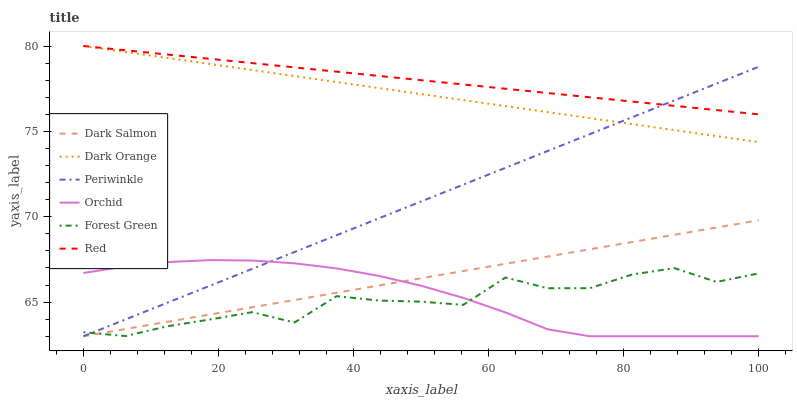Does Forest Green have the minimum area under the curve?
Answer yes or no. Yes. Does Red have the maximum area under the curve?
Answer yes or no. Yes. Does Dark Salmon have the minimum area under the curve?
Answer yes or no. No. Does Dark Salmon have the maximum area under the curve?
Answer yes or no. No. Is Red the smoothest?
Answer yes or no. Yes. Is Forest Green the roughest?
Answer yes or no. Yes. Is Dark Salmon the smoothest?
Answer yes or no. No. Is Dark Salmon the roughest?
Answer yes or no. No. Does Forest Green have the lowest value?
Answer yes or no. No. Does Dark Salmon have the highest value?
Answer yes or no. No. Is Dark Salmon less than Dark Orange?
Answer yes or no. Yes. Is Red greater than Orchid?
Answer yes or no. Yes. Does Dark Salmon intersect Dark Orange?
Answer yes or no. No. 